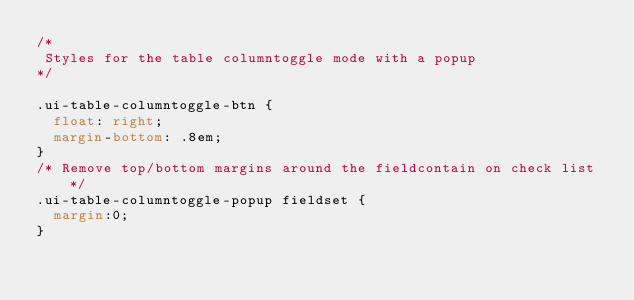<code> <loc_0><loc_0><loc_500><loc_500><_CSS_>/*
 Styles for the table columntoggle mode with a popup
*/

.ui-table-columntoggle-btn {
	float: right;
	margin-bottom: .8em;
}
/* Remove top/bottom margins around the fieldcontain on check list */
.ui-table-columntoggle-popup fieldset {
	margin:0;
}
</code> 